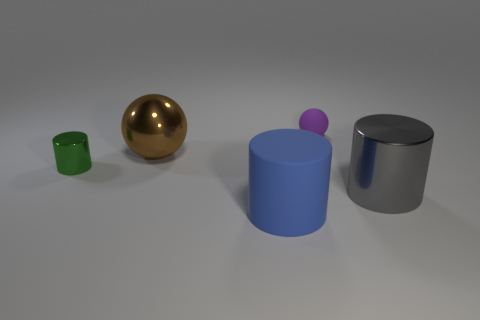Do the tiny object that is behind the small green thing and the large gray thing have the same shape?
Offer a terse response. No. Are there any objects that have the same size as the brown sphere?
Provide a succinct answer. Yes. There is a big matte object; is it the same shape as the large metal thing to the left of the large gray shiny thing?
Your answer should be compact. No. Is the number of small rubber balls left of the tiny rubber object less than the number of small red matte objects?
Give a very brief answer. No. Is the green shiny object the same shape as the tiny purple rubber object?
Your answer should be very brief. No. There is a brown object that is the same material as the large gray cylinder; what is its size?
Provide a succinct answer. Large. Are there fewer rubber things than metallic things?
Offer a terse response. Yes. How many tiny objects are either green things or gray matte cylinders?
Offer a very short reply. 1. How many things are right of the brown object and in front of the purple thing?
Offer a very short reply. 2. Are there more metal cylinders than objects?
Keep it short and to the point. No. 